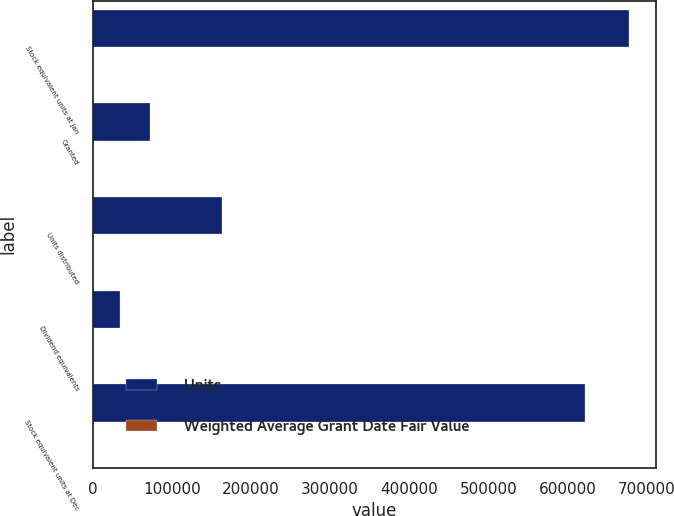Convert chart. <chart><loc_0><loc_0><loc_500><loc_500><stacked_bar_chart><ecel><fcel>Stock equivalent units at Jan<fcel>Granted<fcel>Units distributed<fcel>Dividend equivalents<fcel>Stock equivalent units at Dec<nl><fcel>Units<fcel>677738<fcel>72185<fcel>162923<fcel>34803<fcel>621803<nl><fcel>Weighted Average Grant Date Fair Value<fcel>19.81<fcel>17.87<fcel>19.74<fcel>18.76<fcel>19.5<nl></chart> 